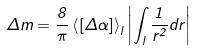<formula> <loc_0><loc_0><loc_500><loc_500>\Delta m = \frac { 8 } { \pi } \left < [ \Delta \alpha ] \right > _ { l } \left | \int _ { l } \frac { 1 } { r ^ { 2 } } d r \right |</formula> 